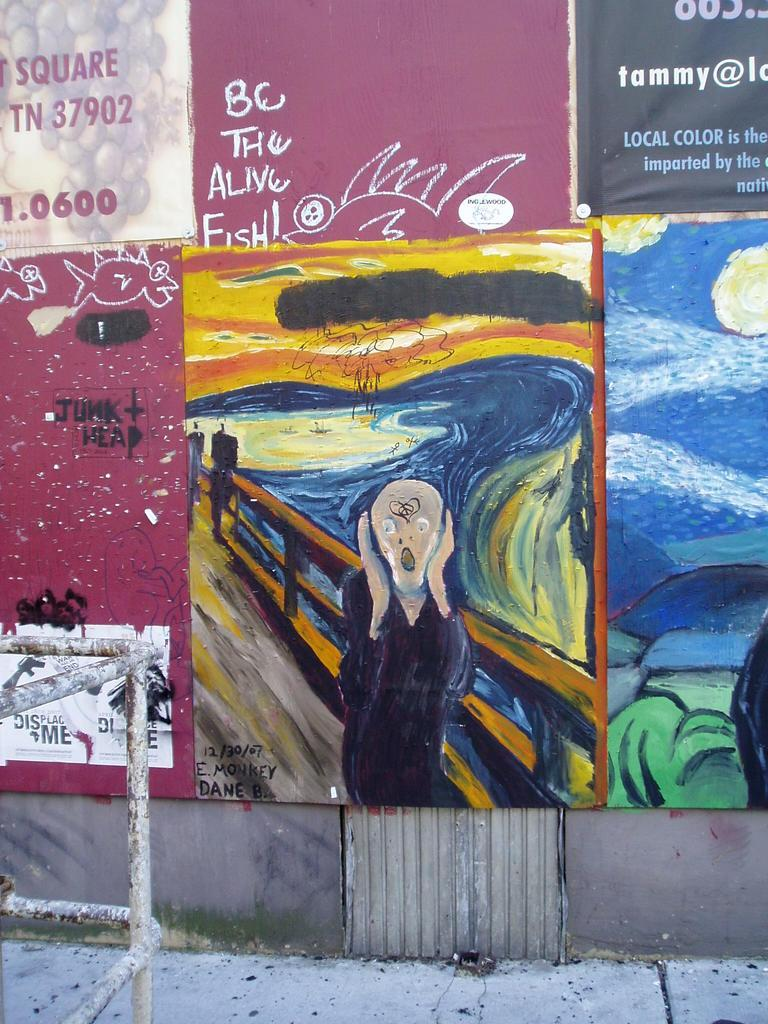<image>
Share a concise interpretation of the image provided. Art lines the city street with graffiti saying 'Be the alive fish!' 